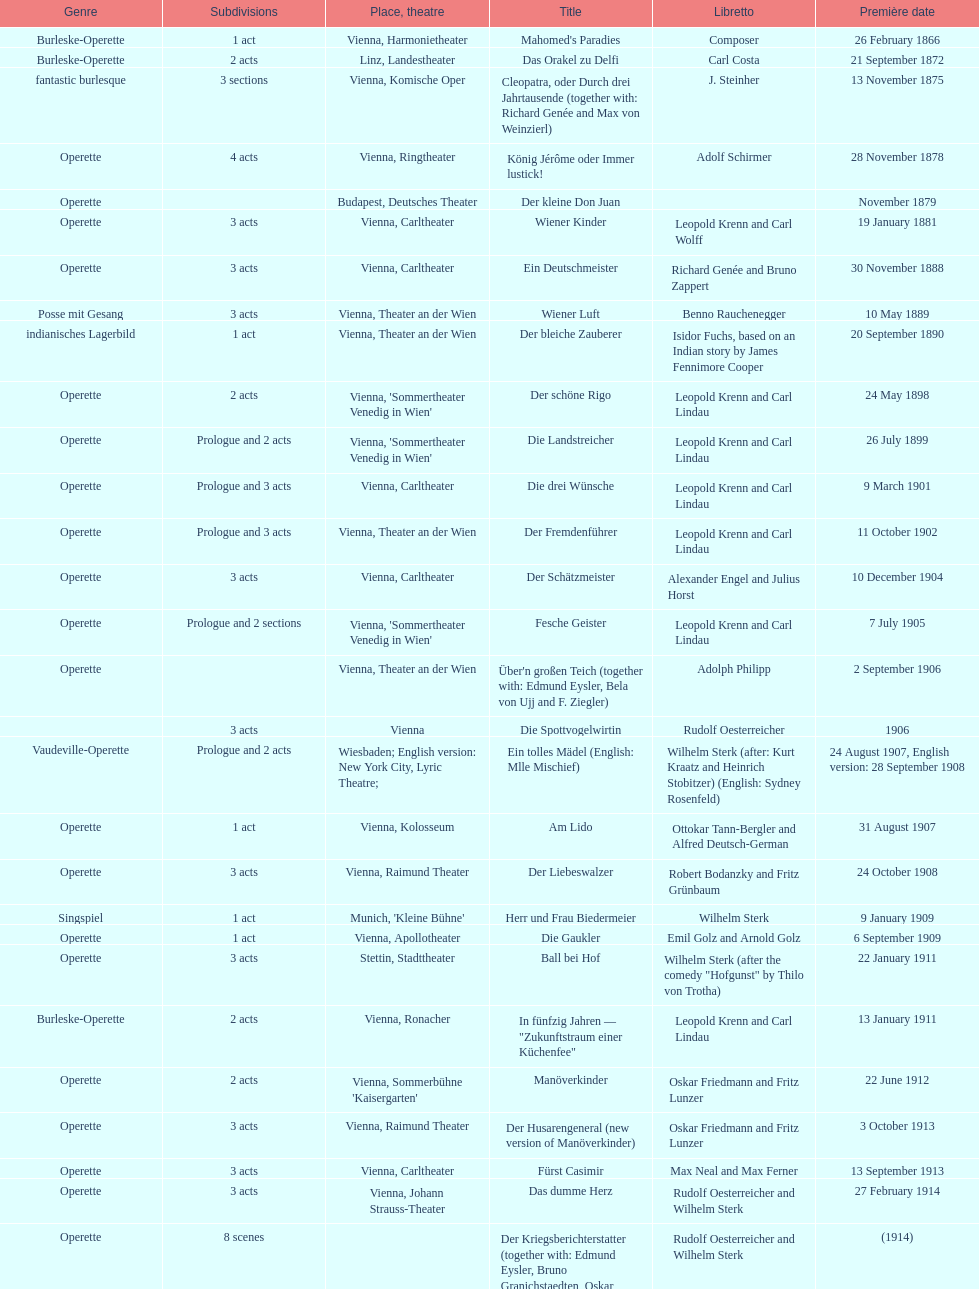What is the count of his operettas that have 3 acts? 13. 